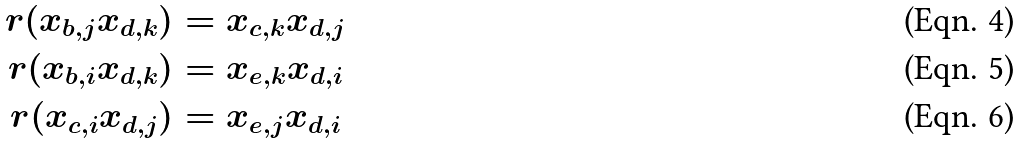<formula> <loc_0><loc_0><loc_500><loc_500>r ( x _ { b , j } x _ { d , k } ) & = x _ { c , k } x _ { d , j } \\ r ( x _ { b , i } x _ { d , k } ) & = x _ { e , k } x _ { d , i } \\ r ( x _ { c , i } x _ { d , j } ) & = x _ { e , j } x _ { d , i }</formula> 